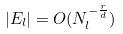<formula> <loc_0><loc_0><loc_500><loc_500>| E _ { l } | = O ( N _ { l } ^ { - \frac { r } { d } } )</formula> 